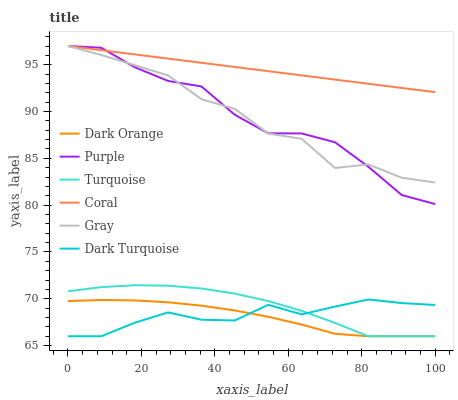Does Turquoise have the minimum area under the curve?
Answer yes or no. No. Does Turquoise have the maximum area under the curve?
Answer yes or no. No. Is Turquoise the smoothest?
Answer yes or no. No. Is Turquoise the roughest?
Answer yes or no. No. Does Gray have the lowest value?
Answer yes or no. No. Does Turquoise have the highest value?
Answer yes or no. No. Is Dark Orange less than Coral?
Answer yes or no. Yes. Is Purple greater than Dark Turquoise?
Answer yes or no. Yes. Does Dark Orange intersect Coral?
Answer yes or no. No. 